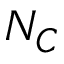<formula> <loc_0><loc_0><loc_500><loc_500>N _ { C }</formula> 